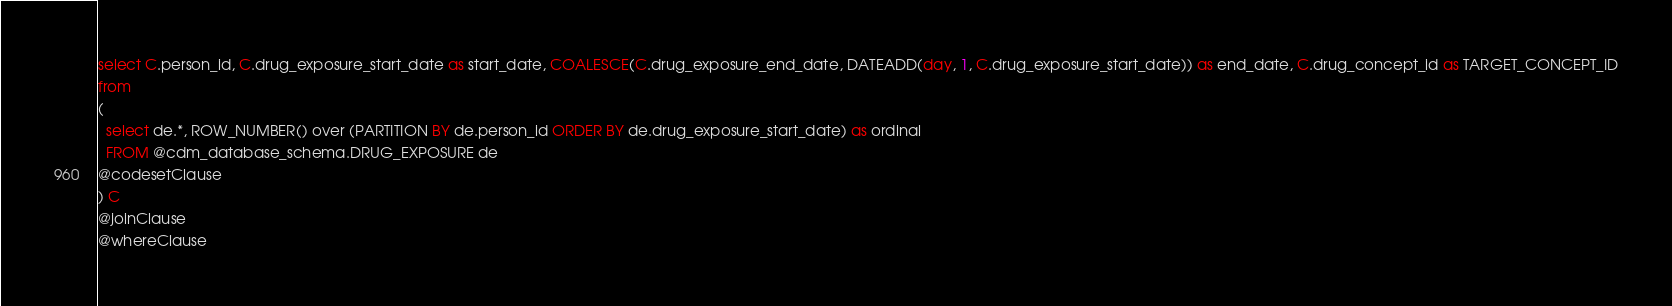Convert code to text. <code><loc_0><loc_0><loc_500><loc_500><_SQL_>select C.person_id, C.drug_exposure_start_date as start_date, COALESCE(C.drug_exposure_end_date, DATEADD(day, 1, C.drug_exposure_start_date)) as end_date, C.drug_concept_id as TARGET_CONCEPT_ID
from 
(
  select de.*, ROW_NUMBER() over (PARTITION BY de.person_id ORDER BY de.drug_exposure_start_date) as ordinal
  FROM @cdm_database_schema.DRUG_EXPOSURE de
@codesetClause
) C
@joinClause
@whereClause
</code> 